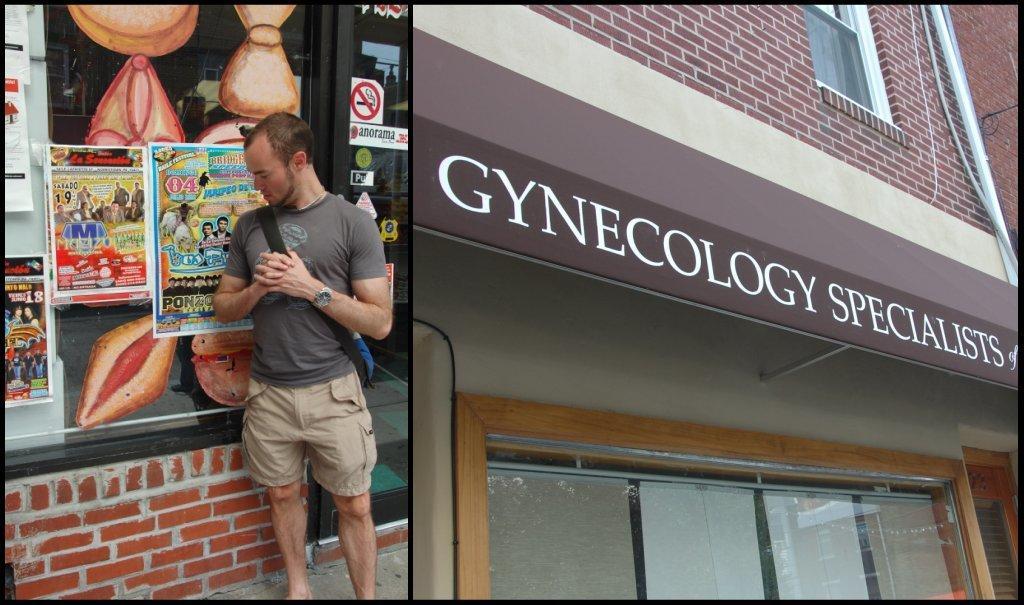Can you describe this image briefly? In this picture there is a man wearing grey color t-shirt and brown shorts standing and looking into the poster which is stick on the mirror. Behind there is a clinic on which "Gynecologist specialist" in written. Above we can see the red color brick wall with window. 